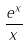Convert formula to latex. <formula><loc_0><loc_0><loc_500><loc_500>\frac { e ^ { x } } { x }</formula> 